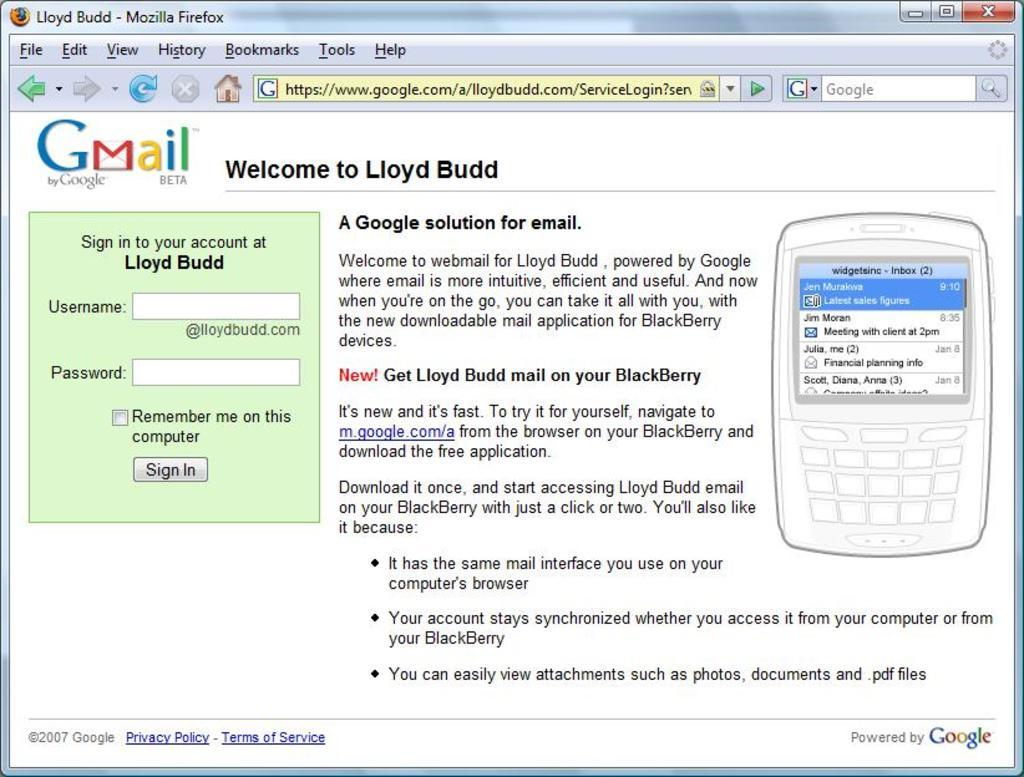<image>
Summarize the visual content of the image. Lloyd Budd's email service is powered by Google. 